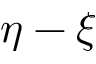Convert formula to latex. <formula><loc_0><loc_0><loc_500><loc_500>\eta - \xi</formula> 